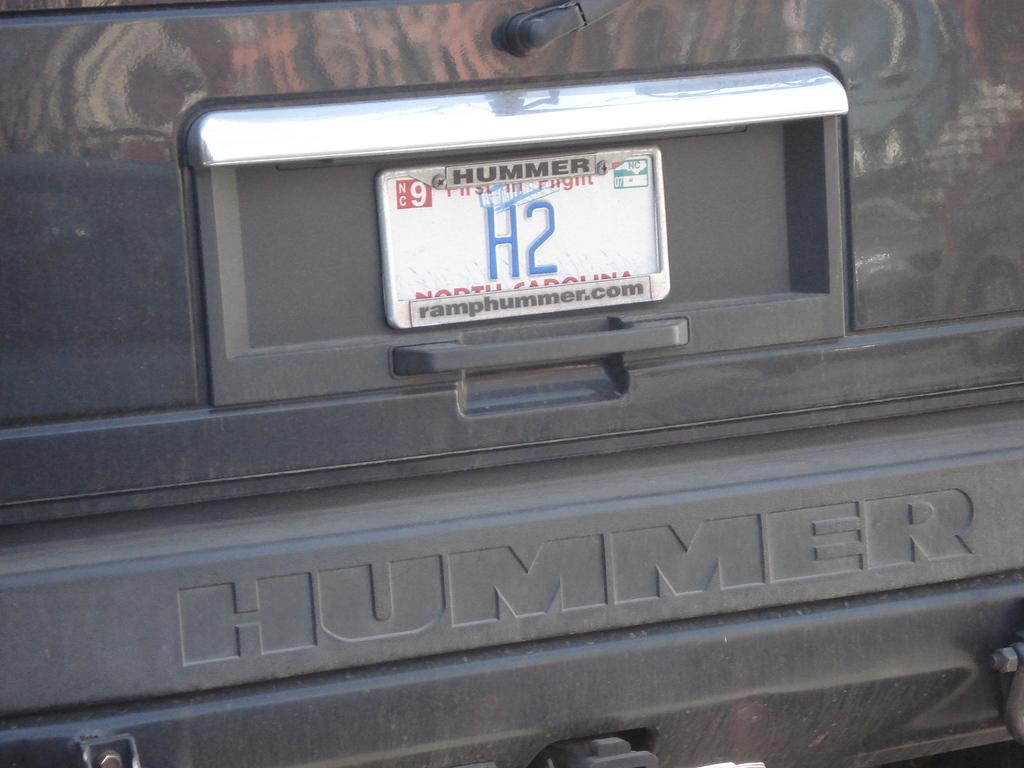<image>
Provide a brief description of the given image. The back bumper of a hummer with the license plate reading H2 on it. 